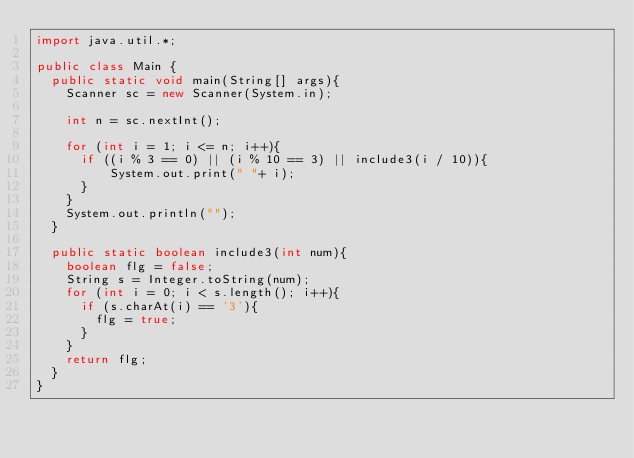Convert code to text. <code><loc_0><loc_0><loc_500><loc_500><_Java_>import java.util.*;

public class Main {
	public static void main(String[] args){
		Scanner sc = new Scanner(System.in);
	    
		int n = sc.nextInt();
		
		for (int i = 1; i <= n; i++){
			if ((i % 3 == 0) || (i % 10 == 3) || include3(i / 10)){
					System.out.print(" "+ i);
			}
		}
		System.out.println("");
	}
	
	public static boolean include3(int num){
		boolean flg = false;
		String s = Integer.toString(num);
		for (int i = 0; i < s.length(); i++){
			if (s.charAt(i) == '3'){
				flg = true;
			}
		}
		return flg;
	}
}</code> 